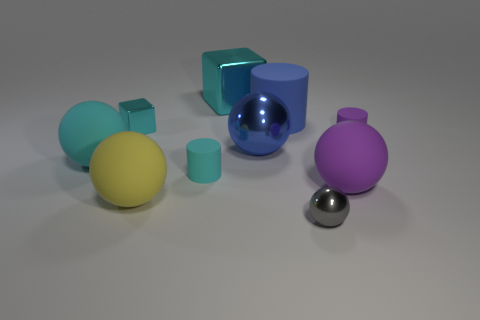Subtract all cyan cubes. How many were subtracted if there are1cyan cubes left? 1 Subtract all small metal spheres. How many spheres are left? 4 Subtract all purple balls. How many balls are left? 4 Subtract 1 cylinders. How many cylinders are left? 2 Subtract all blue spheres. Subtract all red blocks. How many spheres are left? 4 Subtract all cylinders. How many objects are left? 7 Add 2 big yellow spheres. How many big yellow spheres are left? 3 Add 4 big red balls. How many big red balls exist? 4 Subtract 1 gray spheres. How many objects are left? 9 Subtract all tiny cyan metallic cubes. Subtract all large yellow rubber spheres. How many objects are left? 8 